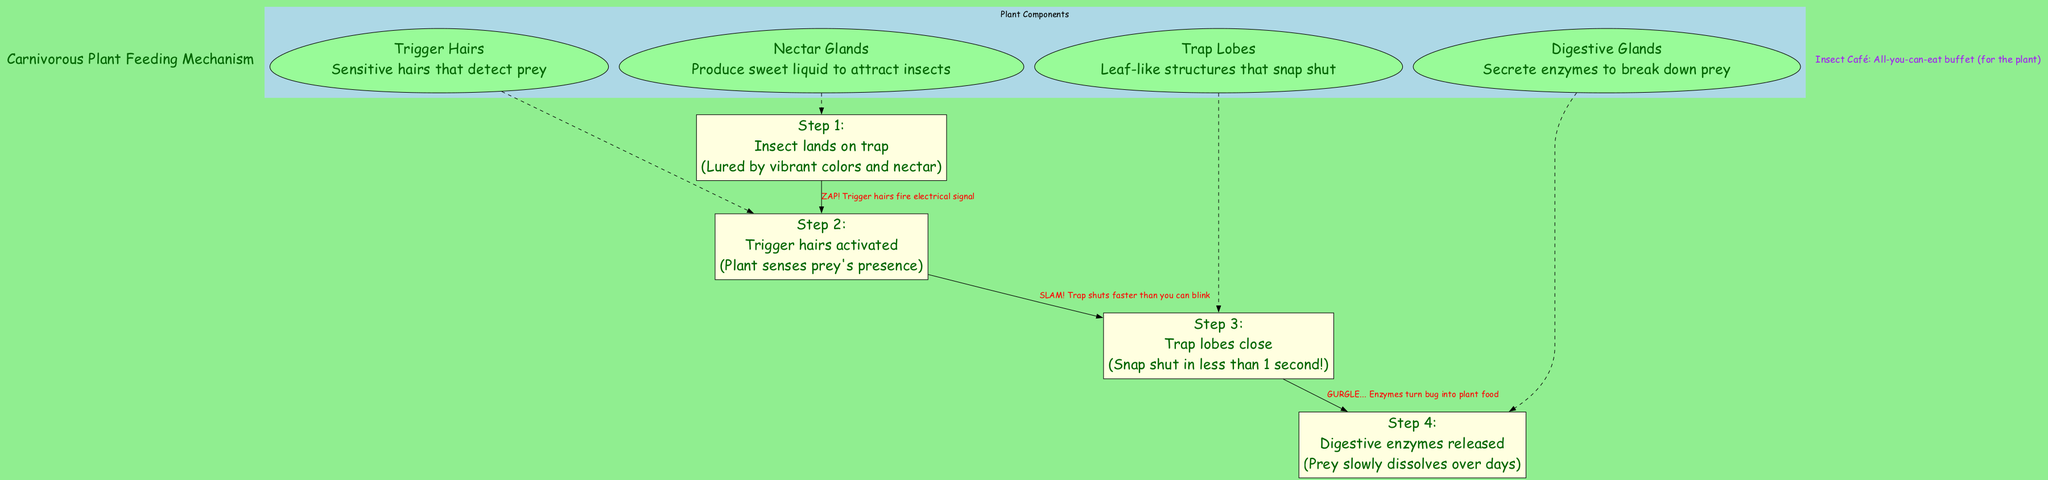What are the sensitive structures that detect prey? According to the diagram, "Trigger Hairs" are described as the sensitive hairs that detect prey. This is clearly indicated in the main components section of the diagram.
Answer: Trigger Hairs What action follows after an insect lands on the trap? The diagram outlines that after an insect lands on the trap, the next action is the "Trigger hairs activated," which shows the flow of events in the feeding process.
Answer: Trigger hairs activated How many main components are there in the diagram? The diagram lists four main components, which include Trigger Hairs, Trap Lobes, Digestive Glands, and Nectar Glands. By counting these components, we confirm there are four.
Answer: 4 What happens within one second of insect detection? The process signifies that the "Trap lobes close" in less than 1 second after the "Trigger hairs activated" step, indicating a quick response from the plant.
Answer: Trap lobes close Which gland produces nectar to attract insects? According to the main components section of the diagram, the "Nectar Glands" are responsible for producing sweet liquid to attract insects. This is a direct description from the content provided.
Answer: Nectar Glands What is the reaction time for the trap lobe to shut? The diagram annotates that the Trap lobes "Snap shut in less than 1 second!" This indicates a very rapid motion, expressed specifically in the comic-style annotations.
Answer: Less than 1 second What do the digestive glands secrete to break down prey? The diagram states that the "Digestive Glands" secrete enzymes which are essential for breaking down the prey after the trap has closed. This information is explicitly mentioned in the description of the main components.
Answer: Enzymes Which step involves enzymes and how long does the dissolution take? The fourth step in the feeding process illustrates that "Digestive enzymes released" takes place, and the note indicates that the prey "slowly dissolves over days," combining two pieces of information from the process section.
Answer: Slowly dissolves over days What is the flow sequence from insect landing to enzyme release? The sequence shows that first an insect lands on the trap, which leads to the activation of trigger hairs, then the trap lobes close, followed by the release of digestive enzymes. This sequence outlines the process step-by-step to indicate how one action leads to another.
Answer: Insect lands, Trigger hairs activated, Trap lobes close, Digestive enzymes released 